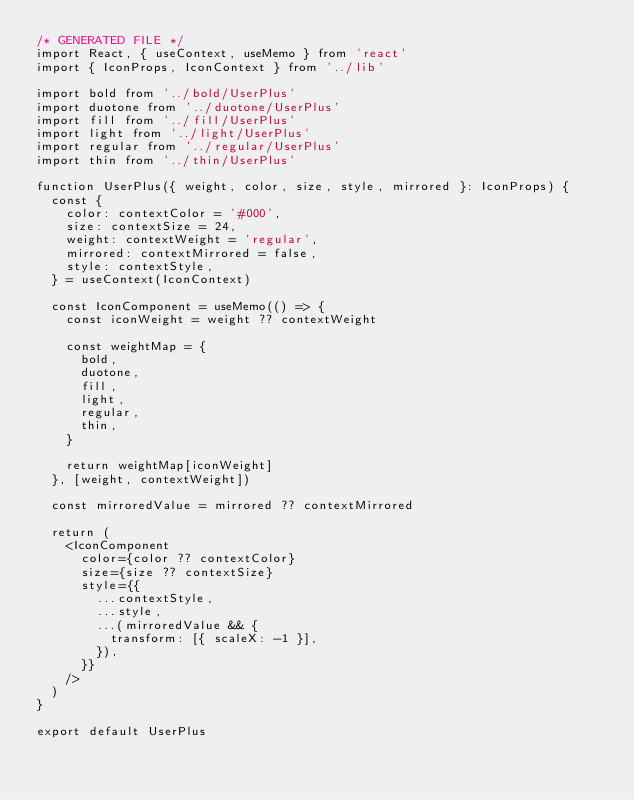<code> <loc_0><loc_0><loc_500><loc_500><_TypeScript_>/* GENERATED FILE */
import React, { useContext, useMemo } from 'react'
import { IconProps, IconContext } from '../lib'

import bold from '../bold/UserPlus'
import duotone from '../duotone/UserPlus'
import fill from '../fill/UserPlus'
import light from '../light/UserPlus'
import regular from '../regular/UserPlus'
import thin from '../thin/UserPlus'

function UserPlus({ weight, color, size, style, mirrored }: IconProps) {
  const {
    color: contextColor = '#000',
    size: contextSize = 24,
    weight: contextWeight = 'regular',
    mirrored: contextMirrored = false, 
    style: contextStyle,
  } = useContext(IconContext)

  const IconComponent = useMemo(() => {
    const iconWeight = weight ?? contextWeight

    const weightMap = {
      bold,
      duotone,
      fill,
      light,
      regular,
      thin,
    }

    return weightMap[iconWeight]
  }, [weight, contextWeight])

  const mirroredValue = mirrored ?? contextMirrored

  return (
    <IconComponent
      color={color ?? contextColor}
      size={size ?? contextSize}
      style={{
        ...contextStyle,
        ...style,
        ...(mirroredValue && {
          transform: [{ scaleX: -1 }],
        }),
      }}
    />
  )
}

export default UserPlus
  </code> 